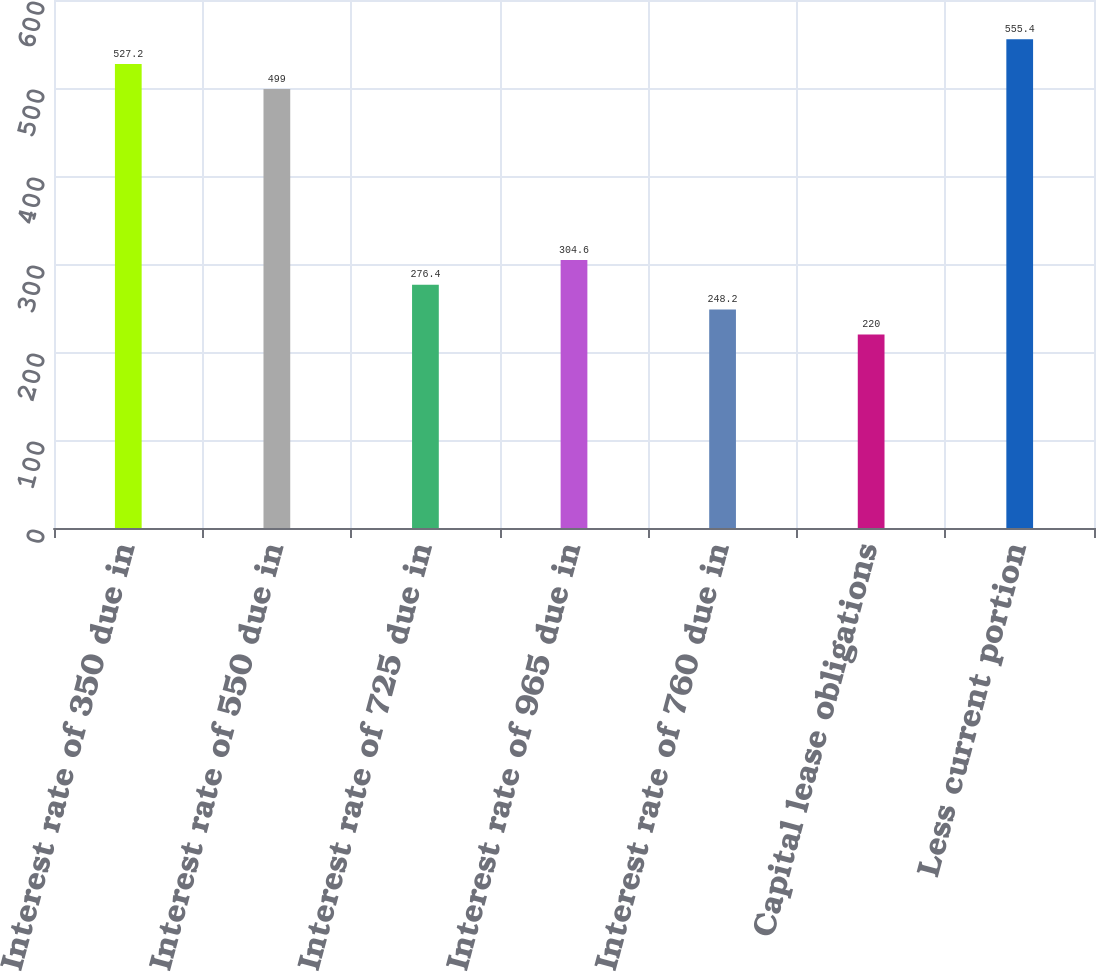Convert chart. <chart><loc_0><loc_0><loc_500><loc_500><bar_chart><fcel>Interest rate of 350 due in<fcel>Interest rate of 550 due in<fcel>Interest rate of 725 due in<fcel>Interest rate of 965 due in<fcel>Interest rate of 760 due in<fcel>Capital lease obligations<fcel>Less current portion<nl><fcel>527.2<fcel>499<fcel>276.4<fcel>304.6<fcel>248.2<fcel>220<fcel>555.4<nl></chart> 